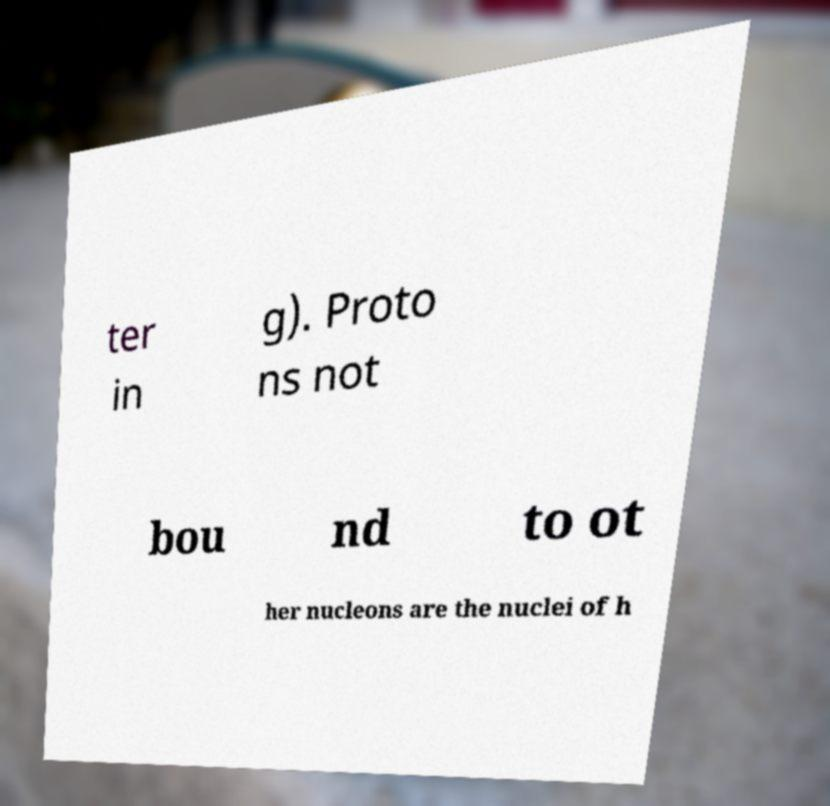There's text embedded in this image that I need extracted. Can you transcribe it verbatim? ter in g). Proto ns not bou nd to ot her nucleons are the nuclei of h 